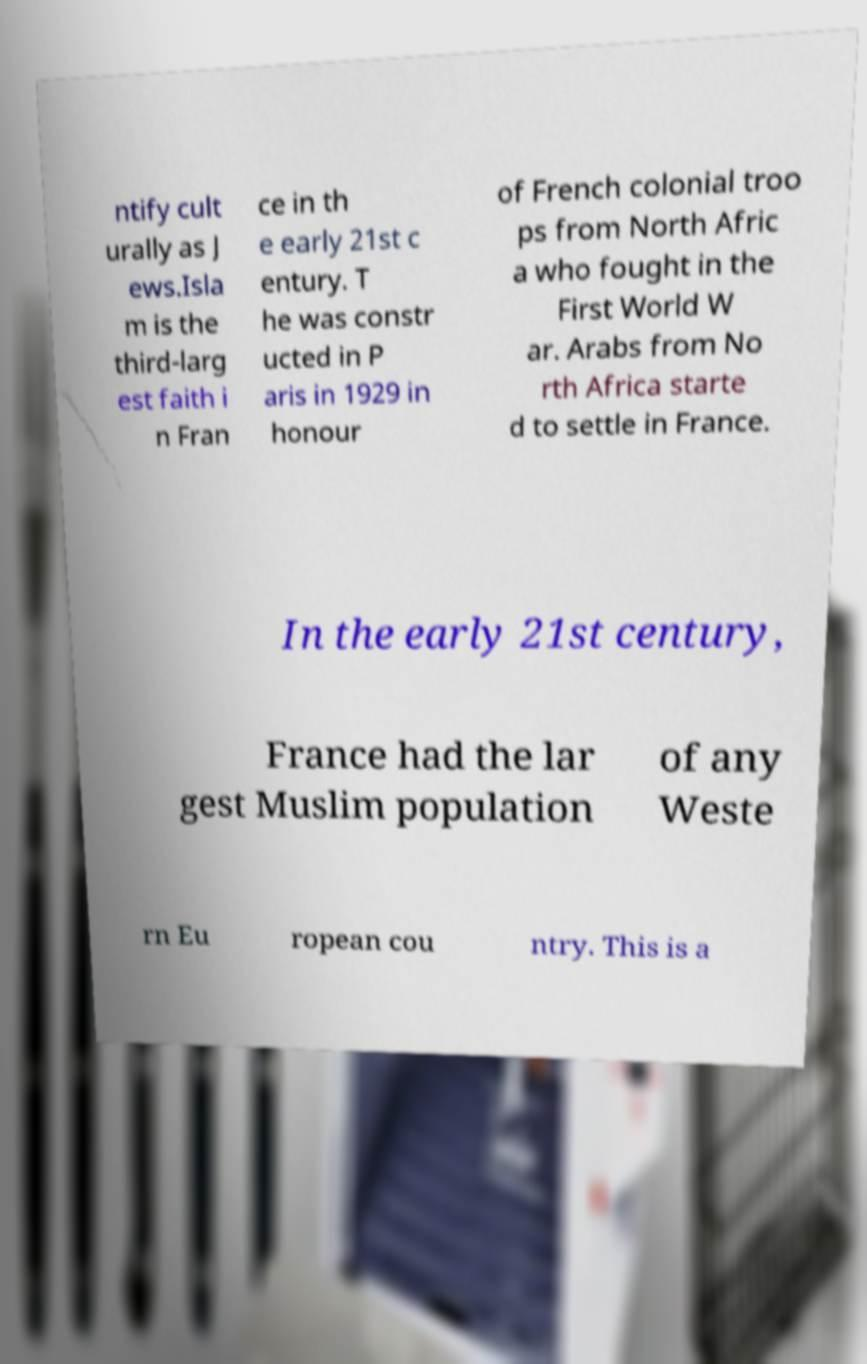There's text embedded in this image that I need extracted. Can you transcribe it verbatim? ntify cult urally as J ews.Isla m is the third-larg est faith i n Fran ce in th e early 21st c entury. T he was constr ucted in P aris in 1929 in honour of French colonial troo ps from North Afric a who fought in the First World W ar. Arabs from No rth Africa starte d to settle in France. In the early 21st century, France had the lar gest Muslim population of any Weste rn Eu ropean cou ntry. This is a 